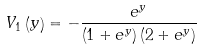<formula> <loc_0><loc_0><loc_500><loc_500>V _ { 1 } \left ( y \right ) & = - \frac { e ^ { y } } { \left ( 1 + e ^ { y } \right ) \left ( 2 + e ^ { y } \right ) }</formula> 